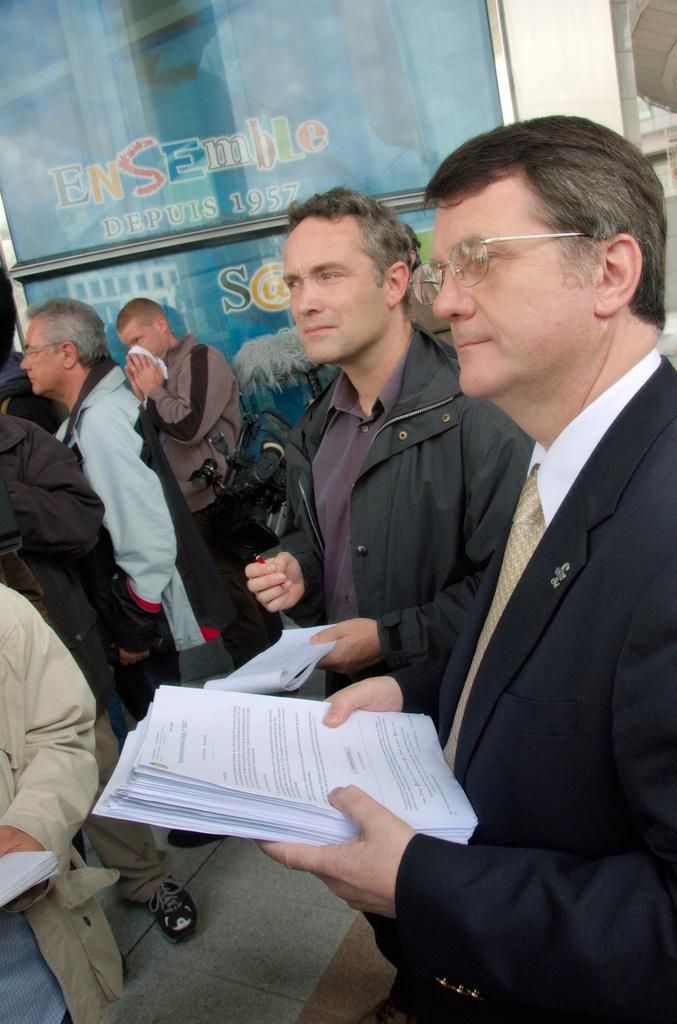What is the main subject of the image? The main subject of the image is a group of people. How can you describe the appearance of the people in the image? The people in the image are wearing different color dresses. What can be seen in the background of the image? There are boards visible in the background of the image. What type of silk is being used to make the boats in the image? There are no boats present in the image, so it is not possible to determine what type of silk might be used. 